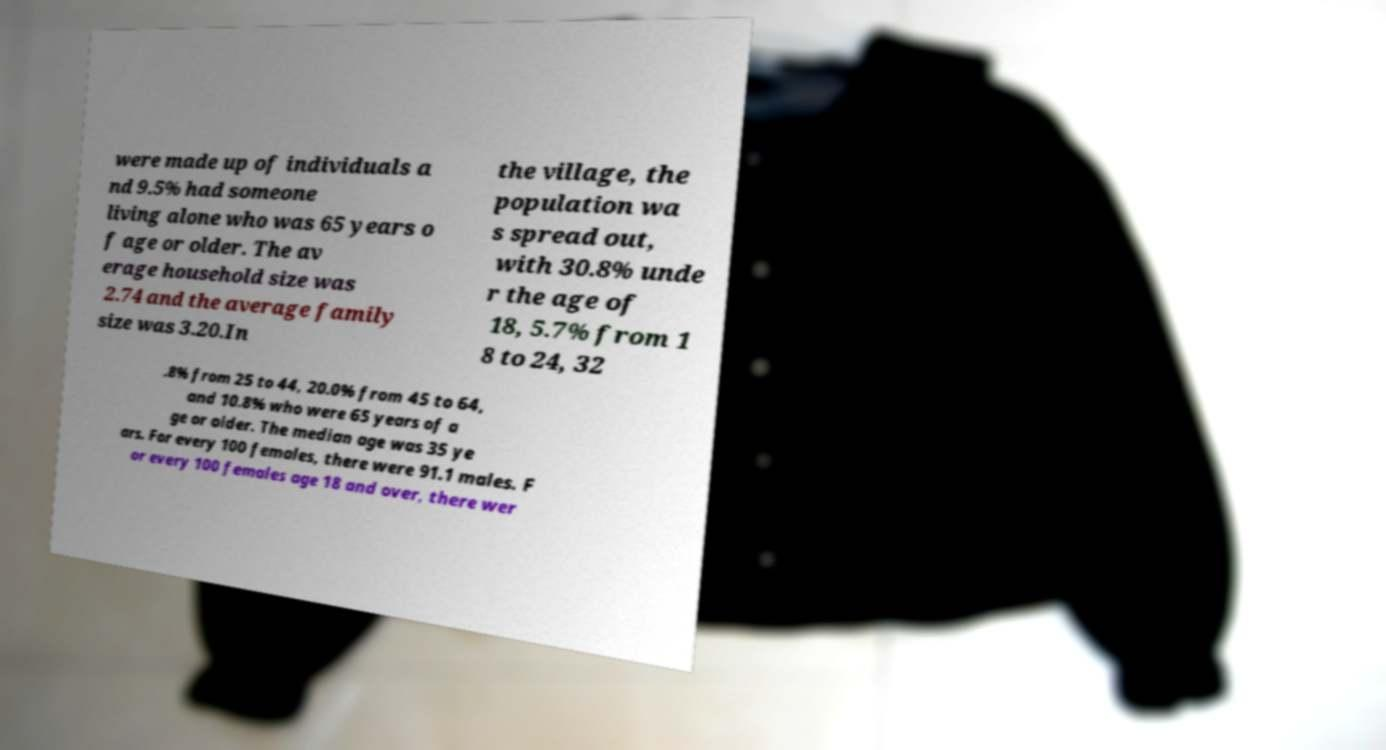There's text embedded in this image that I need extracted. Can you transcribe it verbatim? were made up of individuals a nd 9.5% had someone living alone who was 65 years o f age or older. The av erage household size was 2.74 and the average family size was 3.20.In the village, the population wa s spread out, with 30.8% unde r the age of 18, 5.7% from 1 8 to 24, 32 .8% from 25 to 44, 20.0% from 45 to 64, and 10.8% who were 65 years of a ge or older. The median age was 35 ye ars. For every 100 females, there were 91.1 males. F or every 100 females age 18 and over, there wer 